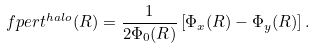<formula> <loc_0><loc_0><loc_500><loc_500>\ f p e r t ^ { h a l o } ( R ) = \frac { 1 } { 2 \Phi _ { 0 } ( R ) } \left [ \Phi _ { x } ( R ) - \Phi _ { y } ( R ) \right ] .</formula> 